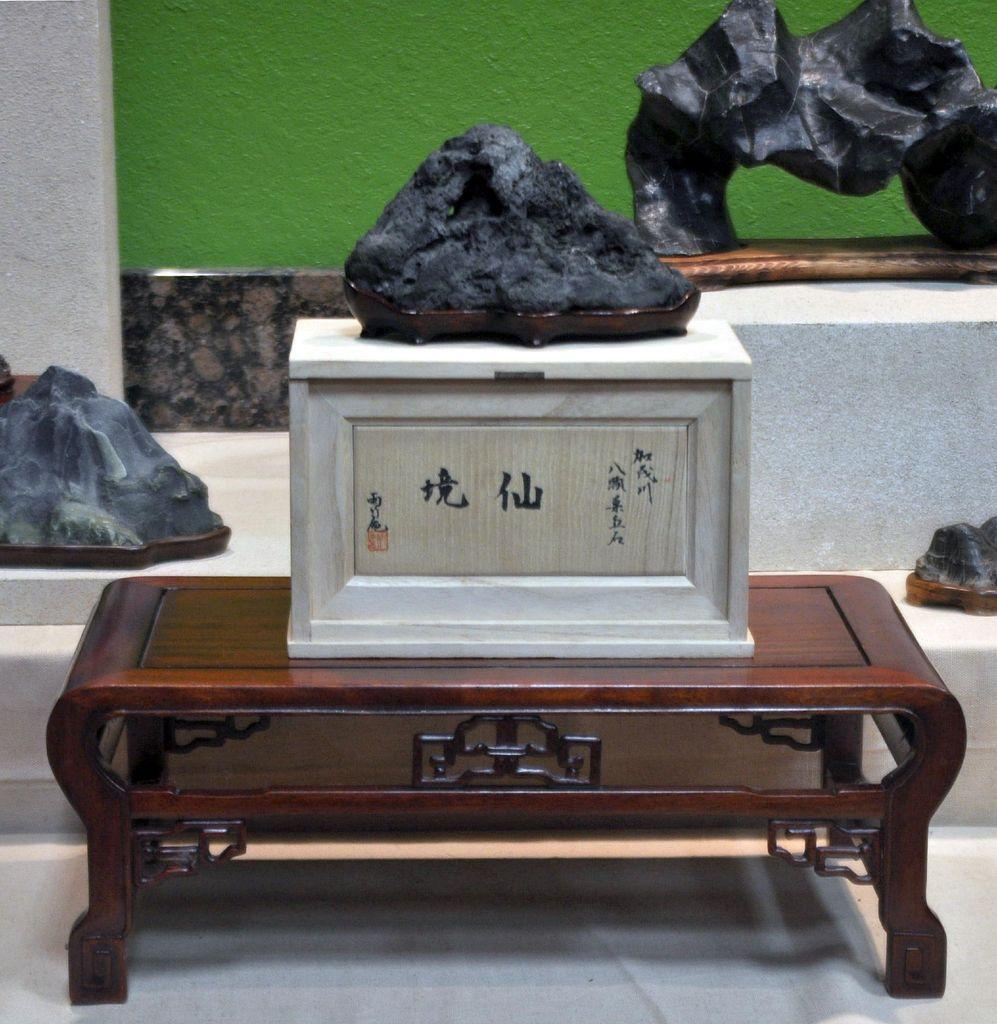Please provide a concise description of this image. In this picture we can see a table on the floor, box, sculptures and some objects and in the background we can see the wall. 